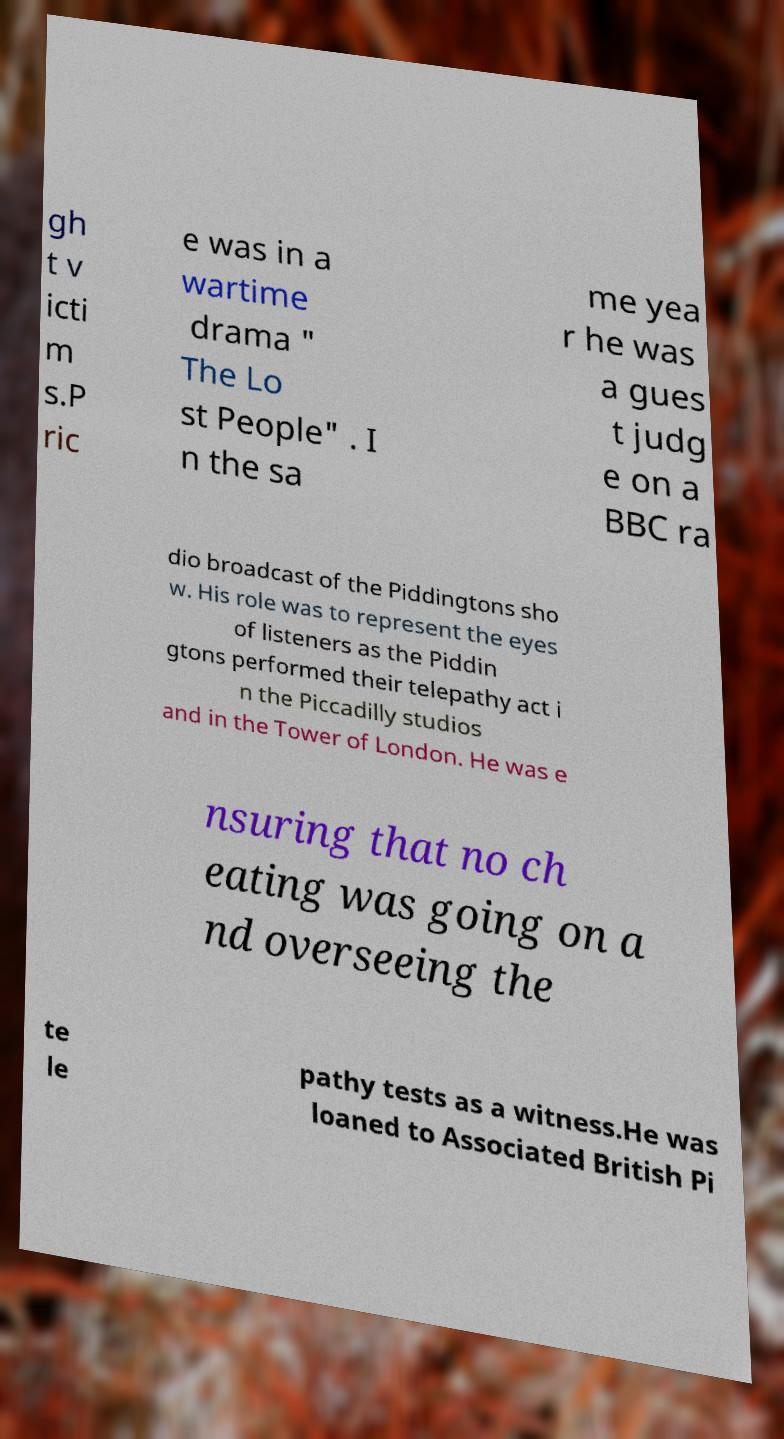I need the written content from this picture converted into text. Can you do that? gh t v icti m s.P ric e was in a wartime drama " The Lo st People" . I n the sa me yea r he was a gues t judg e on a BBC ra dio broadcast of the Piddingtons sho w. His role was to represent the eyes of listeners as the Piddin gtons performed their telepathy act i n the Piccadilly studios and in the Tower of London. He was e nsuring that no ch eating was going on a nd overseeing the te le pathy tests as a witness.He was loaned to Associated British Pi 